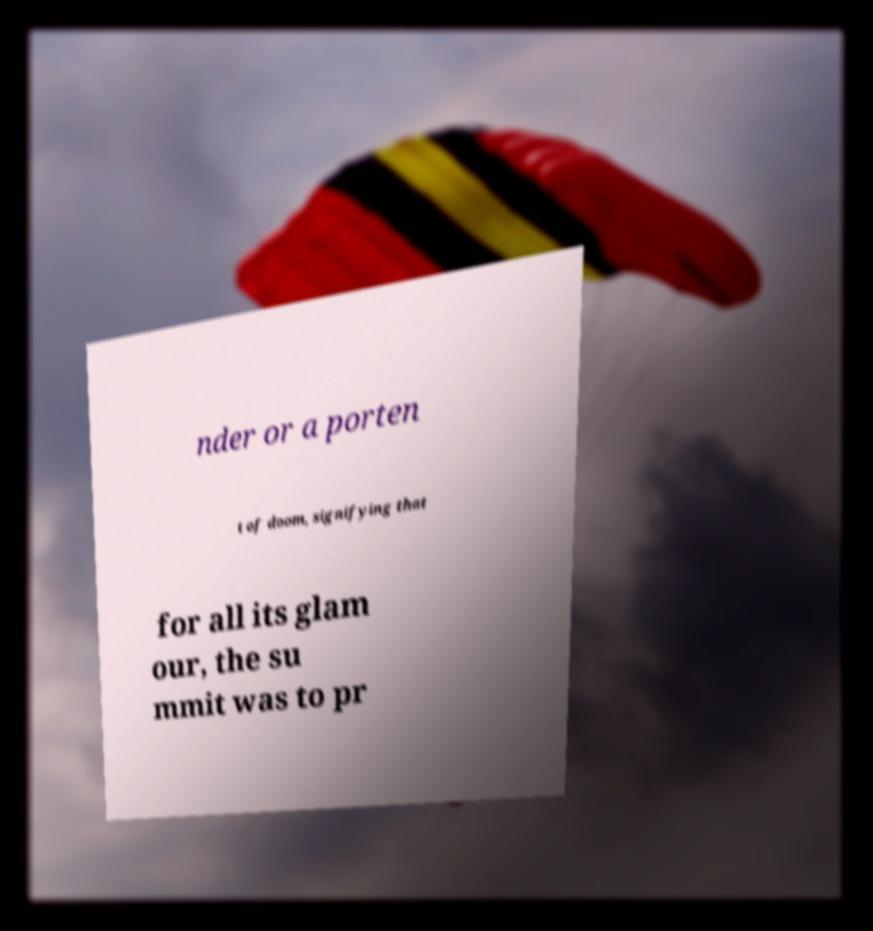Could you assist in decoding the text presented in this image and type it out clearly? nder or a porten t of doom, signifying that for all its glam our, the su mmit was to pr 